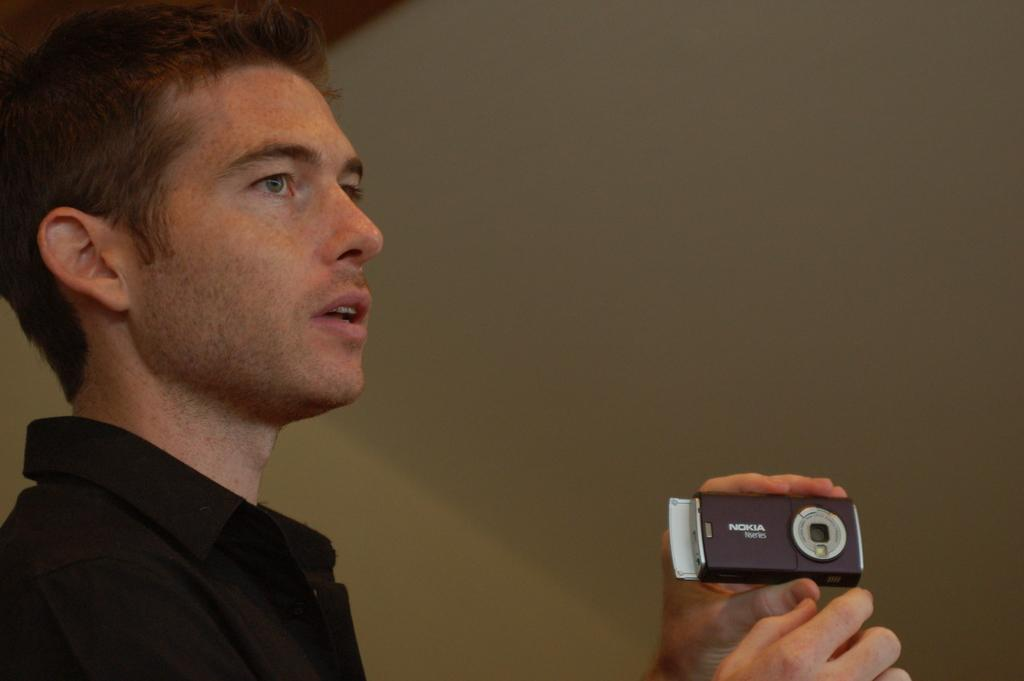What is the main subject of the image? There is a man in the image. What is the man holding in the image? The man is holding a camera. What is the weight of the trees in the image? There are no trees present in the image, so it is not possible to determine their weight. 